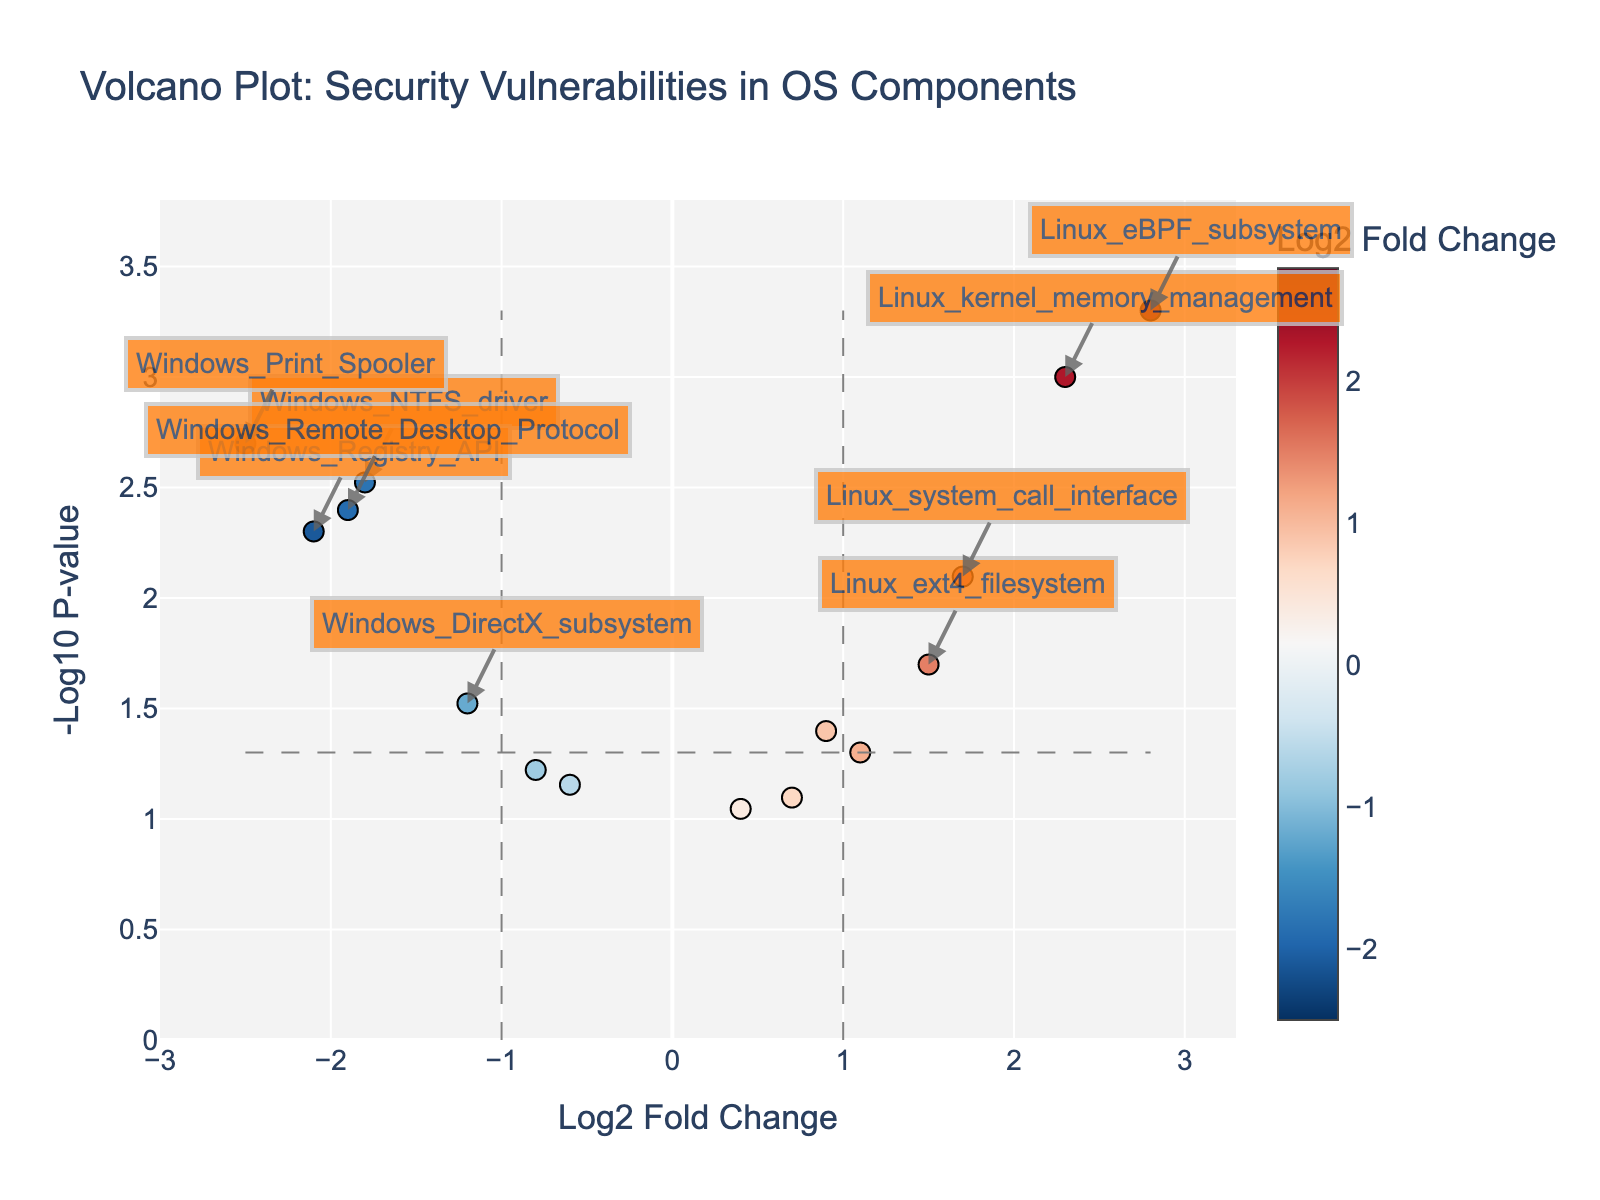What is the title of the plot? The title of the plot is typically found at the top of the figure. It provides a summary of what the figure represents. In this case, the exact text from the provided data and code would be "Volcano Plot: Security Vulnerabilities in OS Components".
Answer: "Volcano Plot: Security Vulnerabilities in OS Components" What does the x-axis represent? The x-axis of the plot is labeled 'Log2 Fold Change', indicating it represents the log2-transformed fold change values of the security vulnerability occurrences between the open-source and proprietary operating system components.
Answer: Log2 Fold Change What does the y-axis represent? The y-axis is labeled as '-Log10 P-value', which means it represents the negative log10-transformed p-values of the security vulnerability occurrences in the components.
Answer: -Log10 P-value How many components are annotated with labels? Components that are both significant in fold change and p-value are annotated with labels. By referring to the detailed code, these components meet the criteria: abs(log2_fold_change) > 1 and p_value < 0.05.
Answer: 7 Which component has the highest -log10 p-value? By visually inspecting the plot, the component with the highest point on the y-axis represents the maximum -log10 p-value. This corresponds to the Linux_eBPF_subsystem.
Answer: Linux_eBPF_subsystem Which components have a negative log2 fold change? Components found on the left side of the y-axis (negative log2 fold change) include Windows_NTFS_driver, Windows_Registry_API, Windows_DirectX_subsystem, Windows_User_Account_Control, Windows_Print_Spooler, Windows_Cryptography_API, Windows_Remote_Desktop_Protocol.
Answer: Windows_NTFS_driver, Windows_Registry_API, Windows_DirectX_subsystem, Windows_User_Account_Control, Windows_Print_Spooler, Windows_Cryptography_API, Windows_Remote_Desktop_Protocol What color scale is used for the markers, and what does it represent? The color scale of the markers goes from red to blue (RdBu_r) and represents the log2 fold change values of the security vulnerabilities, where a more significant fold change is indicated by more intense colors.
Answer: RdBu_r, Log2 Fold Change Which components are most significantly different in terms of security vulnerabilities? Components that are furthest from the origin both horizontally (in log2 fold change) and vertically (in -log10 p-value) are the most significantly different. These include Linux_eBPF_subsystem, Linux_kernel_memory_management, Windows_Print_Spooler, and Windows_Registry_API.
Answer: Linux_eBPF_subsystem, Linux_kernel_memory_management, Windows_Print_Spooler, Windows_Registry_API Are there more components with positive or negative log2 fold change? To answer this, count the number of data points on either side of the y-axis (center line).
Answer: More negative What can you infer about the security vulnerabilities of Linux and Windows components based on their positions in the plot? Components with a log2 fold change greater than 0 (right side) indicate higher vulnerability occurrences in Linux, while those less than 0 (left side) indicate higher vulnerability occurrences in Windows. The vertical position (-log10 p-value) indicates the significance of these differences.
Answer: Linux is more vulnerable in its memory management and eBPF subsystems, while Windows has higher vulnerabilities in NTFS driver, Registry API, and Print Spooler 